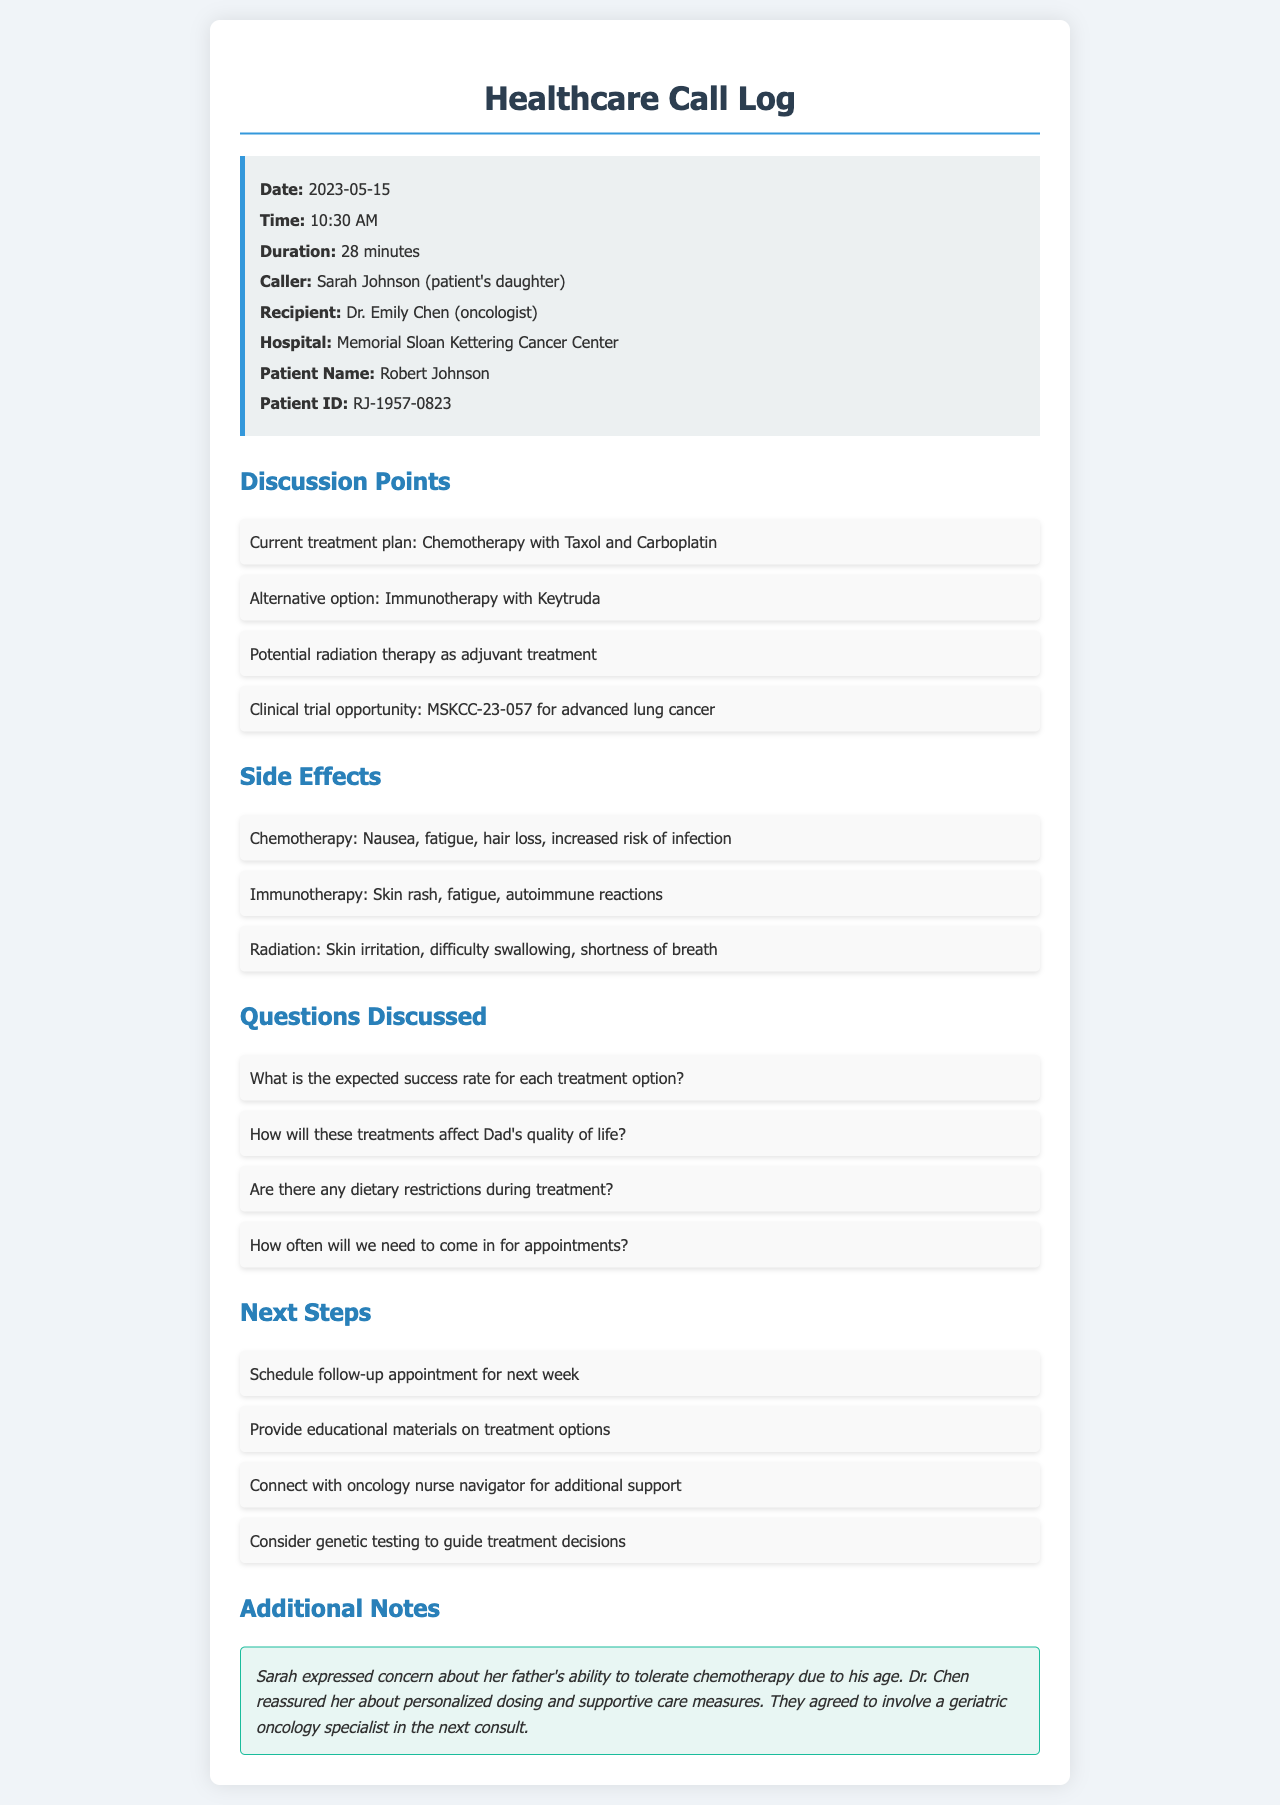What is the date of the call? The date of the call is provided in the header section of the document.
Answer: 2023-05-15 Who is the healthcare provider that Sarah spoke with? The recipient is mentioned at the beginning of the document.
Answer: Dr. Emily Chen What is the current treatment plan for Robert Johnson? The current treatment plan is listed under the discussion points.
Answer: Chemotherapy with Taxol and Carboplatin What are two potential side effects of immunotherapy? The side effects are listed in bullet points, specifically for immunotherapy.
Answer: Skin rash, fatigue What are the next steps discussed during the call? The next steps are outlined in a separate section of the document.
Answer: Schedule follow-up appointment for next week What is the clinical trial opportunity mentioned? The clinical trial opportunity is provided in the discussion points.
Answer: MSKCC-23-057 for advanced lung cancer How long was the call? The duration of the call is included in the call info section.
Answer: 28 minutes What concern did Sarah express regarding her father's treatment? The concern is noted in the additional notes section of the document.
Answer: Ability to tolerate chemotherapy How often will they need to come in for appointments? The frequency of appointments is one of the questions discussed during the call.
Answer: Not specified in document 